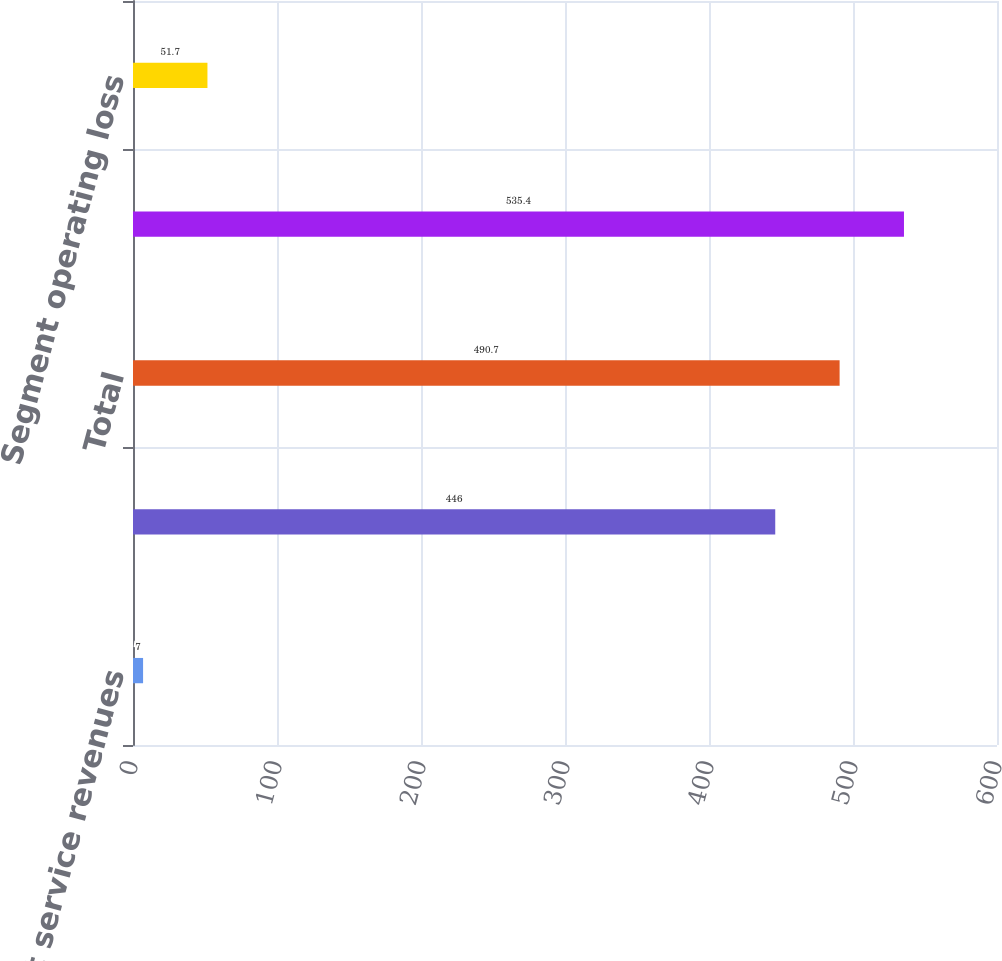Convert chart. <chart><loc_0><loc_0><loc_500><loc_500><bar_chart><fcel>Net patient service revenues<fcel>Other revenues<fcel>Total<fcel>Total net revenues<fcel>Segment operating loss<nl><fcel>7<fcel>446<fcel>490.7<fcel>535.4<fcel>51.7<nl></chart> 